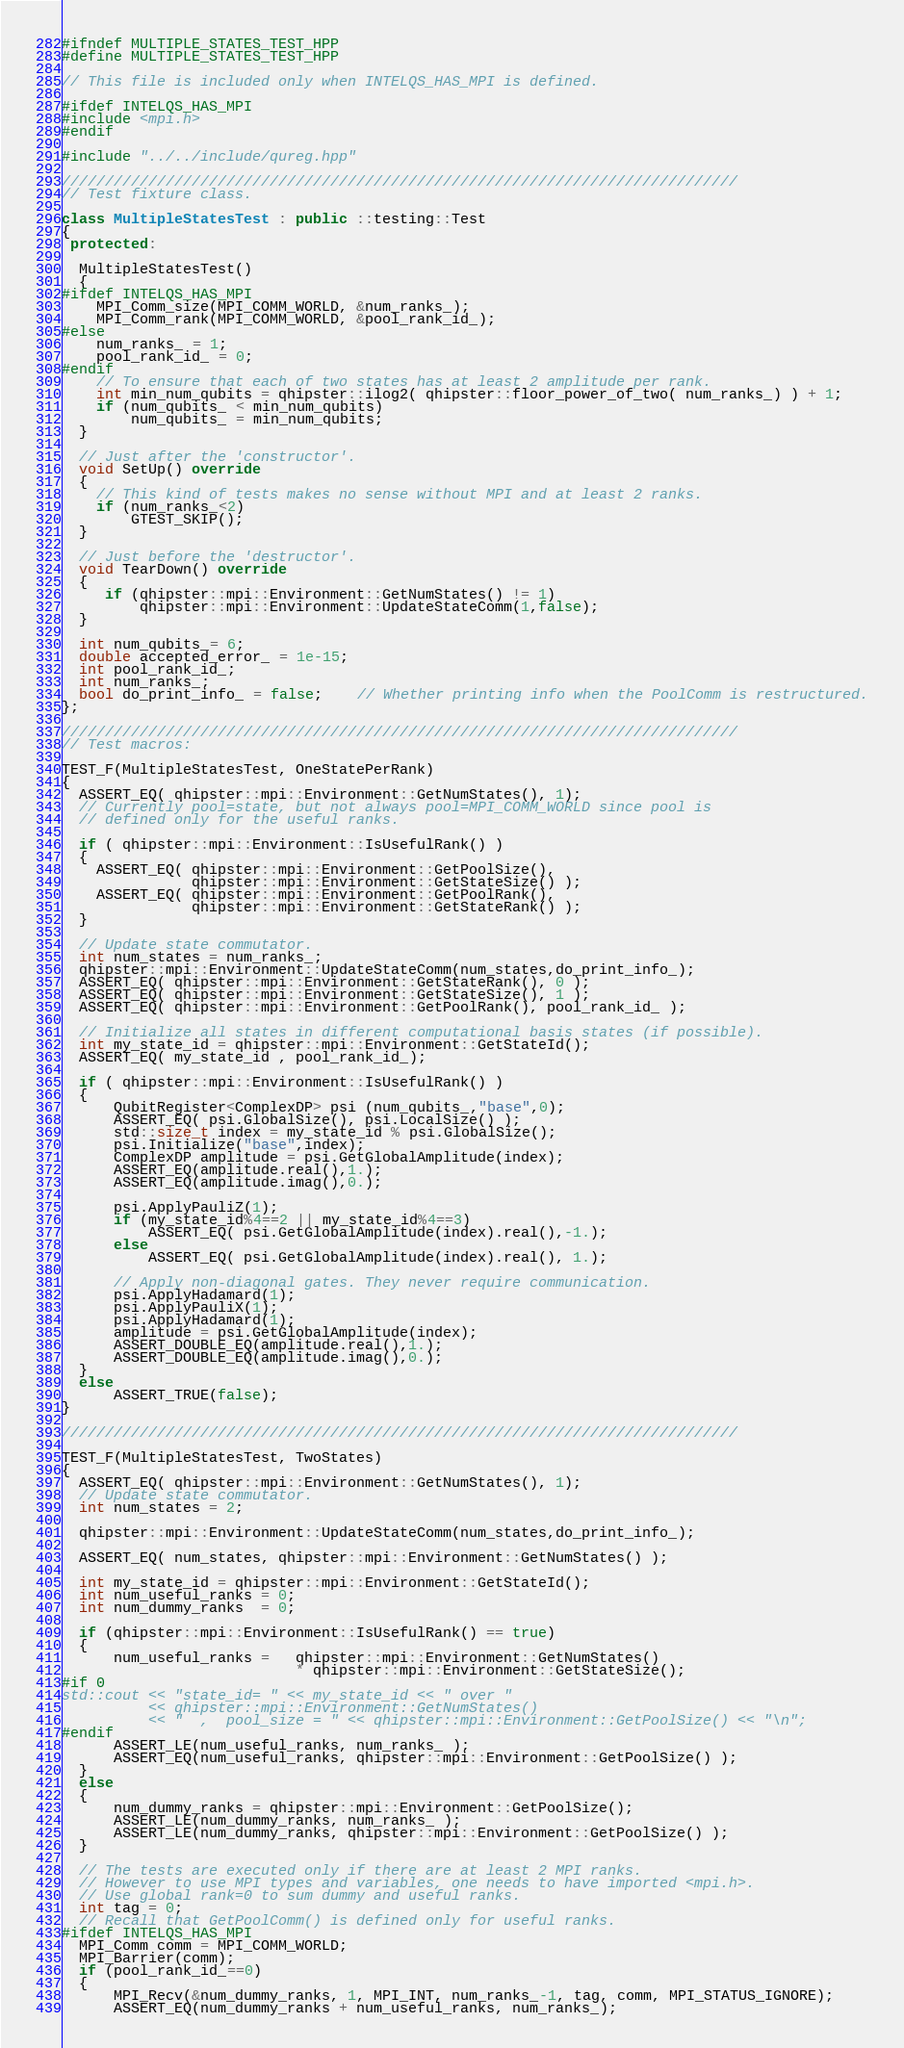Convert code to text. <code><loc_0><loc_0><loc_500><loc_500><_C++_>#ifndef MULTIPLE_STATES_TEST_HPP
#define MULTIPLE_STATES_TEST_HPP

// This file is included only when INTELQS_HAS_MPI is defined.

#ifdef INTELQS_HAS_MPI
#include <mpi.h>
#endif

#include "../../include/qureg.hpp"

//////////////////////////////////////////////////////////////////////////////
// Test fixture class.

class MultipleStatesTest : public ::testing::Test
{
 protected:

  MultipleStatesTest()
  {
#ifdef INTELQS_HAS_MPI
    MPI_Comm_size(MPI_COMM_WORLD, &num_ranks_);
    MPI_Comm_rank(MPI_COMM_WORLD, &pool_rank_id_);
#else
    num_ranks_ = 1;
    pool_rank_id_ = 0;
#endif
    // To ensure that each of two states has at least 2 amplitude per rank.
    int min_num_qubits = qhipster::ilog2( qhipster::floor_power_of_two( num_ranks_) ) + 1;
    if (num_qubits_ < min_num_qubits)
        num_qubits_ = min_num_qubits;
  }

  // Just after the 'constructor'.
  void SetUp() override
  {
    // This kind of tests makes no sense without MPI and at least 2 ranks.
    if (num_ranks_<2)
        GTEST_SKIP();
  }

  // Just before the 'destructor'.
  void TearDown() override
  {
     if (qhipster::mpi::Environment::GetNumStates() != 1)
         qhipster::mpi::Environment::UpdateStateComm(1,false);
  }

  int num_qubits_= 6;
  double accepted_error_ = 1e-15;
  int pool_rank_id_;
  int num_ranks_;
  bool do_print_info_ = false;	// Whether printing info when the PoolComm is restructured.
};

//////////////////////////////////////////////////////////////////////////////
// Test macros:

TEST_F(MultipleStatesTest, OneStatePerRank)
{
  ASSERT_EQ( qhipster::mpi::Environment::GetNumStates(), 1);
  // Currently pool=state, but not always pool=MPI_COMM_WORLD since pool is
  // defined only for the useful ranks.

  if ( qhipster::mpi::Environment::IsUsefulRank() )
  {
    ASSERT_EQ( qhipster::mpi::Environment::GetPoolSize(),
               qhipster::mpi::Environment::GetStateSize() );
    ASSERT_EQ( qhipster::mpi::Environment::GetPoolRank(),
               qhipster::mpi::Environment::GetStateRank() );
  }
  
  // Update state commutator.
  int num_states = num_ranks_;
  qhipster::mpi::Environment::UpdateStateComm(num_states,do_print_info_);
  ASSERT_EQ( qhipster::mpi::Environment::GetStateRank(), 0 );
  ASSERT_EQ( qhipster::mpi::Environment::GetStateSize(), 1 );
  ASSERT_EQ( qhipster::mpi::Environment::GetPoolRank(), pool_rank_id_ );

  // Initialize all states in different computational basis states (if possible).
  int my_state_id = qhipster::mpi::Environment::GetStateId();
  ASSERT_EQ( my_state_id , pool_rank_id_);

  if ( qhipster::mpi::Environment::IsUsefulRank() )
  {
      QubitRegister<ComplexDP> psi (num_qubits_,"base",0);
      ASSERT_EQ( psi.GlobalSize(), psi.LocalSize() );
      std::size_t index = my_state_id % psi.GlobalSize();
      psi.Initialize("base",index);
      ComplexDP amplitude = psi.GetGlobalAmplitude(index);
      ASSERT_EQ(amplitude.real(),1.);
      ASSERT_EQ(amplitude.imag(),0.);

      psi.ApplyPauliZ(1);
      if (my_state_id%4==2 || my_state_id%4==3)
          ASSERT_EQ( psi.GetGlobalAmplitude(index).real(),-1.);
      else
          ASSERT_EQ( psi.GetGlobalAmplitude(index).real(), 1.);

      // Apply non-diagonal gates. They never require communication.
      psi.ApplyHadamard(1);
      psi.ApplyPauliX(1);
      psi.ApplyHadamard(1);
      amplitude = psi.GetGlobalAmplitude(index);
      ASSERT_DOUBLE_EQ(amplitude.real(),1.);
      ASSERT_DOUBLE_EQ(amplitude.imag(),0.);
  }
  else
      ASSERT_TRUE(false);
}

//////////////////////////////////////////////////////////////////////////////

TEST_F(MultipleStatesTest, TwoStates)
{
  ASSERT_EQ( qhipster::mpi::Environment::GetNumStates(), 1);
  // Update state commutator.
  int num_states = 2;

  qhipster::mpi::Environment::UpdateStateComm(num_states,do_print_info_);

  ASSERT_EQ( num_states, qhipster::mpi::Environment::GetNumStates() );

  int my_state_id = qhipster::mpi::Environment::GetStateId();
  int num_useful_ranks = 0;
  int num_dummy_ranks  = 0;

  if (qhipster::mpi::Environment::IsUsefulRank() == true)
  {
      num_useful_ranks =   qhipster::mpi::Environment::GetNumStates()
                           * qhipster::mpi::Environment::GetStateSize();
#if 0
std::cout << "state_id= " << my_state_id << " over "
          << qhipster::mpi::Environment::GetNumStates()
          << "  ,  pool_size = " << qhipster::mpi::Environment::GetPoolSize() << "\n";
#endif
      ASSERT_LE(num_useful_ranks, num_ranks_ );
      ASSERT_EQ(num_useful_ranks, qhipster::mpi::Environment::GetPoolSize() );
  }
  else
  {
      num_dummy_ranks = qhipster::mpi::Environment::GetPoolSize();
      ASSERT_LE(num_dummy_ranks, num_ranks_ );
      ASSERT_LE(num_dummy_ranks, qhipster::mpi::Environment::GetPoolSize() );
  }

  // The tests are executed only if there are at least 2 MPI ranks.
  // However to use MPI types and variables, one needs to have imported <mpi.h>.
  // Use global rank=0 to sum dummy and useful ranks.
  int tag = 0;
  // Recall that GetPoolComm() is defined only for useful ranks.
#ifdef INTELQS_HAS_MPI
  MPI_Comm comm = MPI_COMM_WORLD;
  MPI_Barrier(comm);
  if (pool_rank_id_==0)
  {
      MPI_Recv(&num_dummy_ranks, 1, MPI_INT, num_ranks_-1, tag, comm, MPI_STATUS_IGNORE);
      ASSERT_EQ(num_dummy_ranks + num_useful_ranks, num_ranks_);</code> 